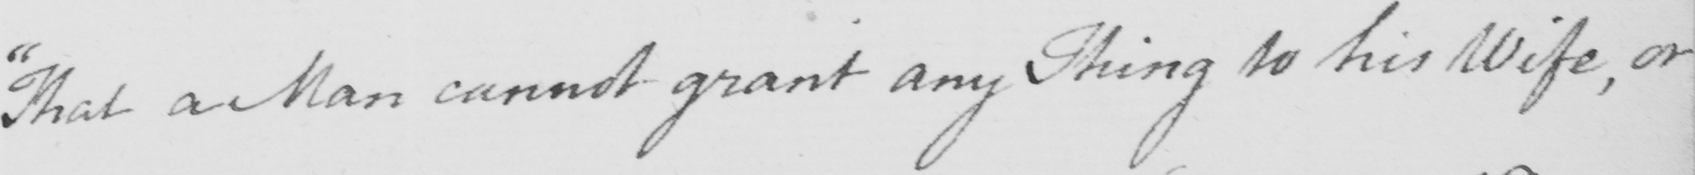What does this handwritten line say? " That a Man cannot grant any Thing to his Wife , or 